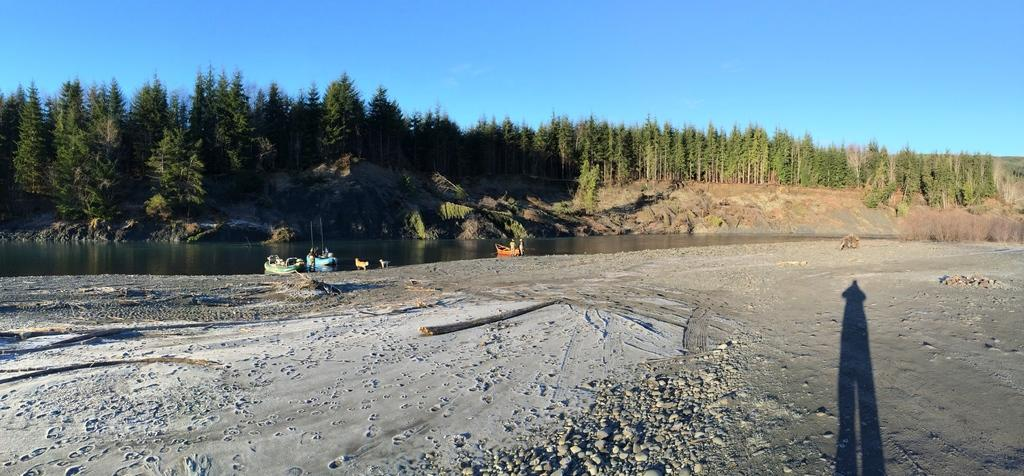What is the main subject of the image? The main subject of the image is boats. Where are the boats located in the image? The boats are on the water surface. What type of vegetation can be seen in the image? There are trees visible in the image. How many lizards can be seen climbing the wire in the image? There are no lizards or wire present in the image. What type of shake is being prepared in the image? There is no shake being prepared in the image; it features boats on the water surface with trees visible in the background. 